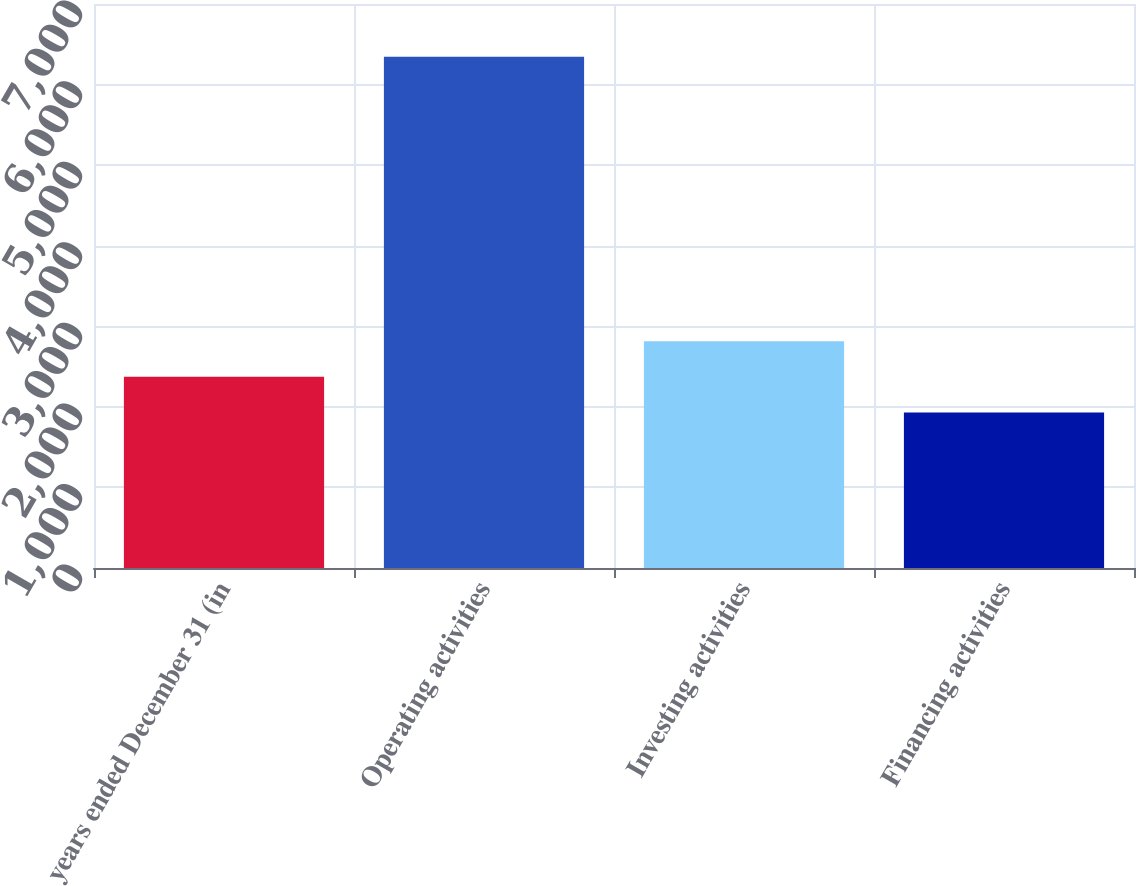<chart> <loc_0><loc_0><loc_500><loc_500><bar_chart><fcel>years ended December 31 (in<fcel>Operating activities<fcel>Investing activities<fcel>Financing activities<nl><fcel>2372.4<fcel>6345<fcel>2813.8<fcel>1931<nl></chart> 